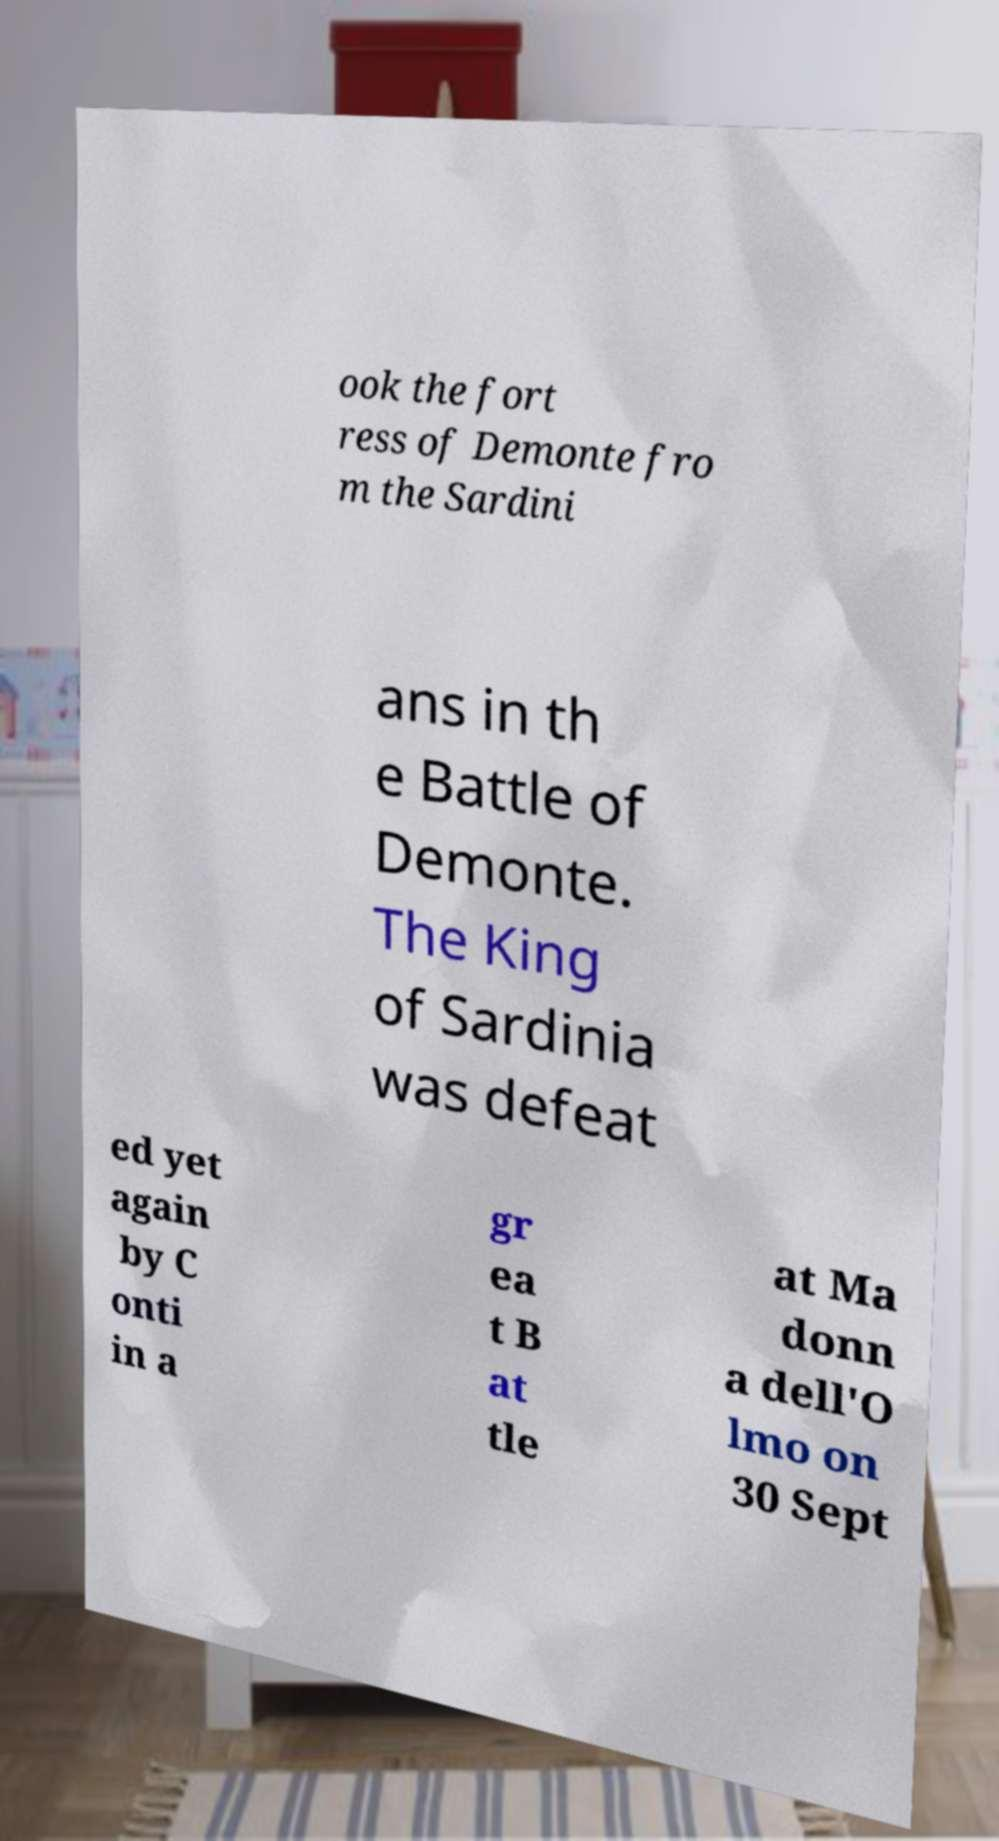Please read and relay the text visible in this image. What does it say? ook the fort ress of Demonte fro m the Sardini ans in th e Battle of Demonte. The King of Sardinia was defeat ed yet again by C onti in a gr ea t B at tle at Ma donn a dell'O lmo on 30 Sept 